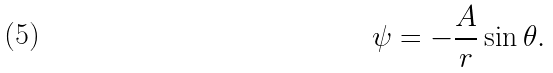Convert formula to latex. <formula><loc_0><loc_0><loc_500><loc_500>\psi = - { \frac { A } { r } } \sin \theta .</formula> 